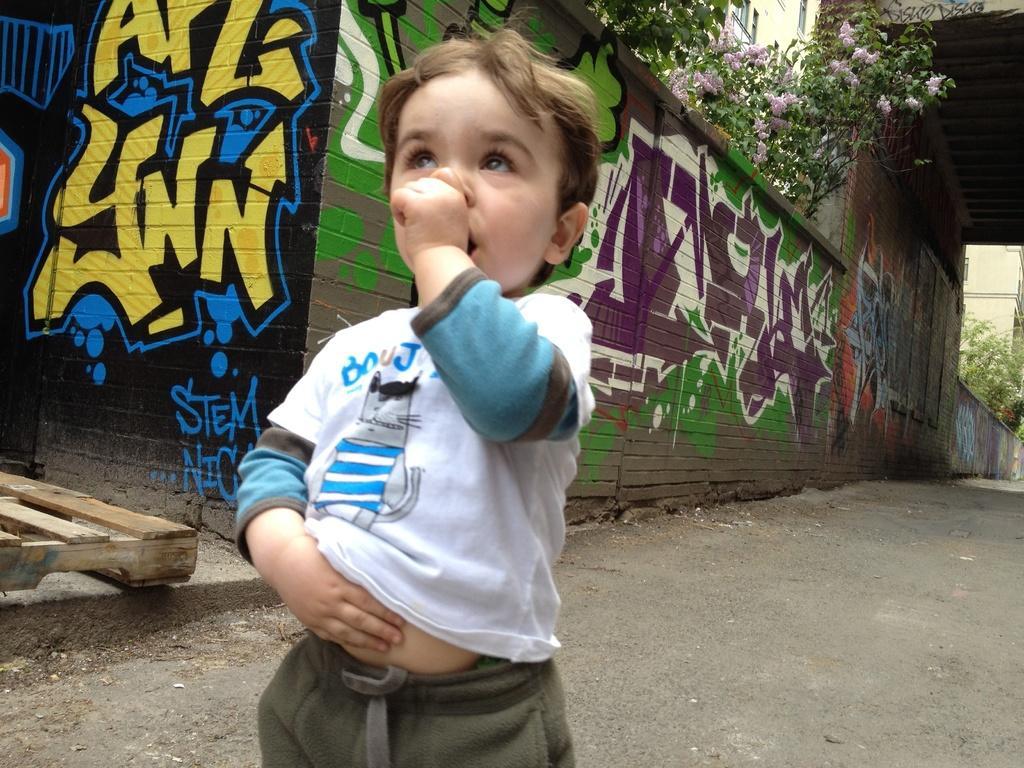In one or two sentences, can you explain what this image depicts? In the center of the image we can see a boy is standing and keeping his hand in his mouth. In the background of the image we can see the wall. On wall we can see graffiti. At the top of the image we can see the trees, flowers, buildings, windows, bridge. At the bottom of the image we can see the road. On the left side of the image we can see a wood. 